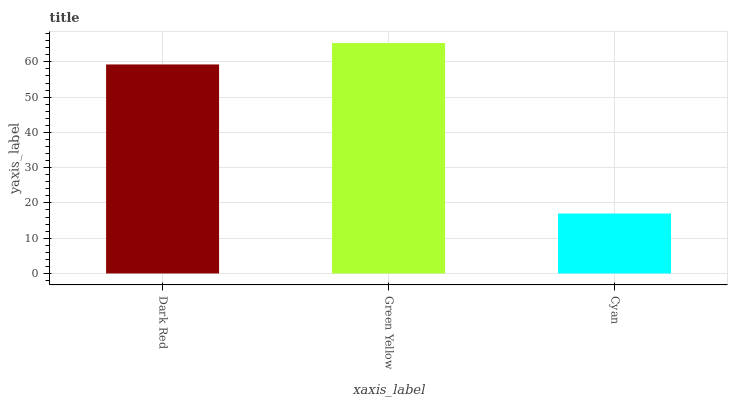Is Cyan the minimum?
Answer yes or no. Yes. Is Green Yellow the maximum?
Answer yes or no. Yes. Is Green Yellow the minimum?
Answer yes or no. No. Is Cyan the maximum?
Answer yes or no. No. Is Green Yellow greater than Cyan?
Answer yes or no. Yes. Is Cyan less than Green Yellow?
Answer yes or no. Yes. Is Cyan greater than Green Yellow?
Answer yes or no. No. Is Green Yellow less than Cyan?
Answer yes or no. No. Is Dark Red the high median?
Answer yes or no. Yes. Is Dark Red the low median?
Answer yes or no. Yes. Is Cyan the high median?
Answer yes or no. No. Is Green Yellow the low median?
Answer yes or no. No. 